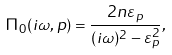Convert formula to latex. <formula><loc_0><loc_0><loc_500><loc_500>\Pi _ { 0 } ( i \omega , { p } ) = \frac { 2 n \varepsilon _ { p } } { ( i \omega ) ^ { 2 } - \varepsilon _ { p } ^ { 2 } } ,</formula> 